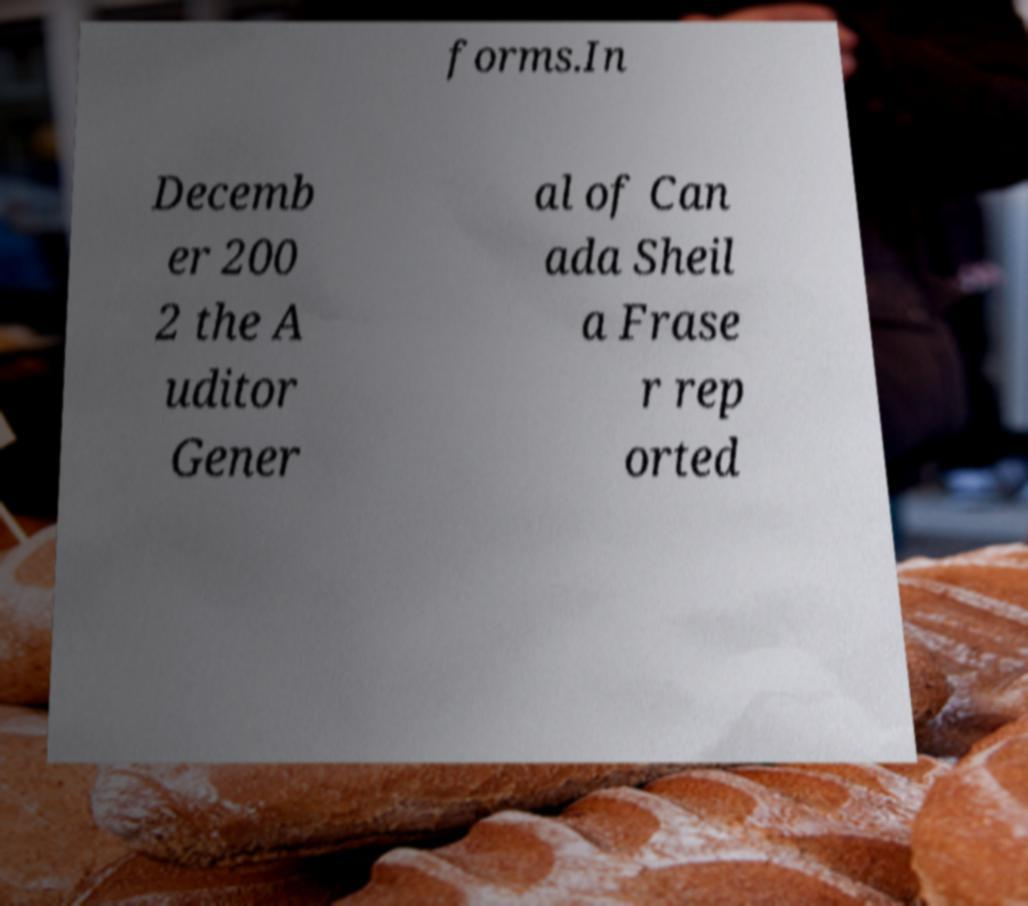There's text embedded in this image that I need extracted. Can you transcribe it verbatim? forms.In Decemb er 200 2 the A uditor Gener al of Can ada Sheil a Frase r rep orted 